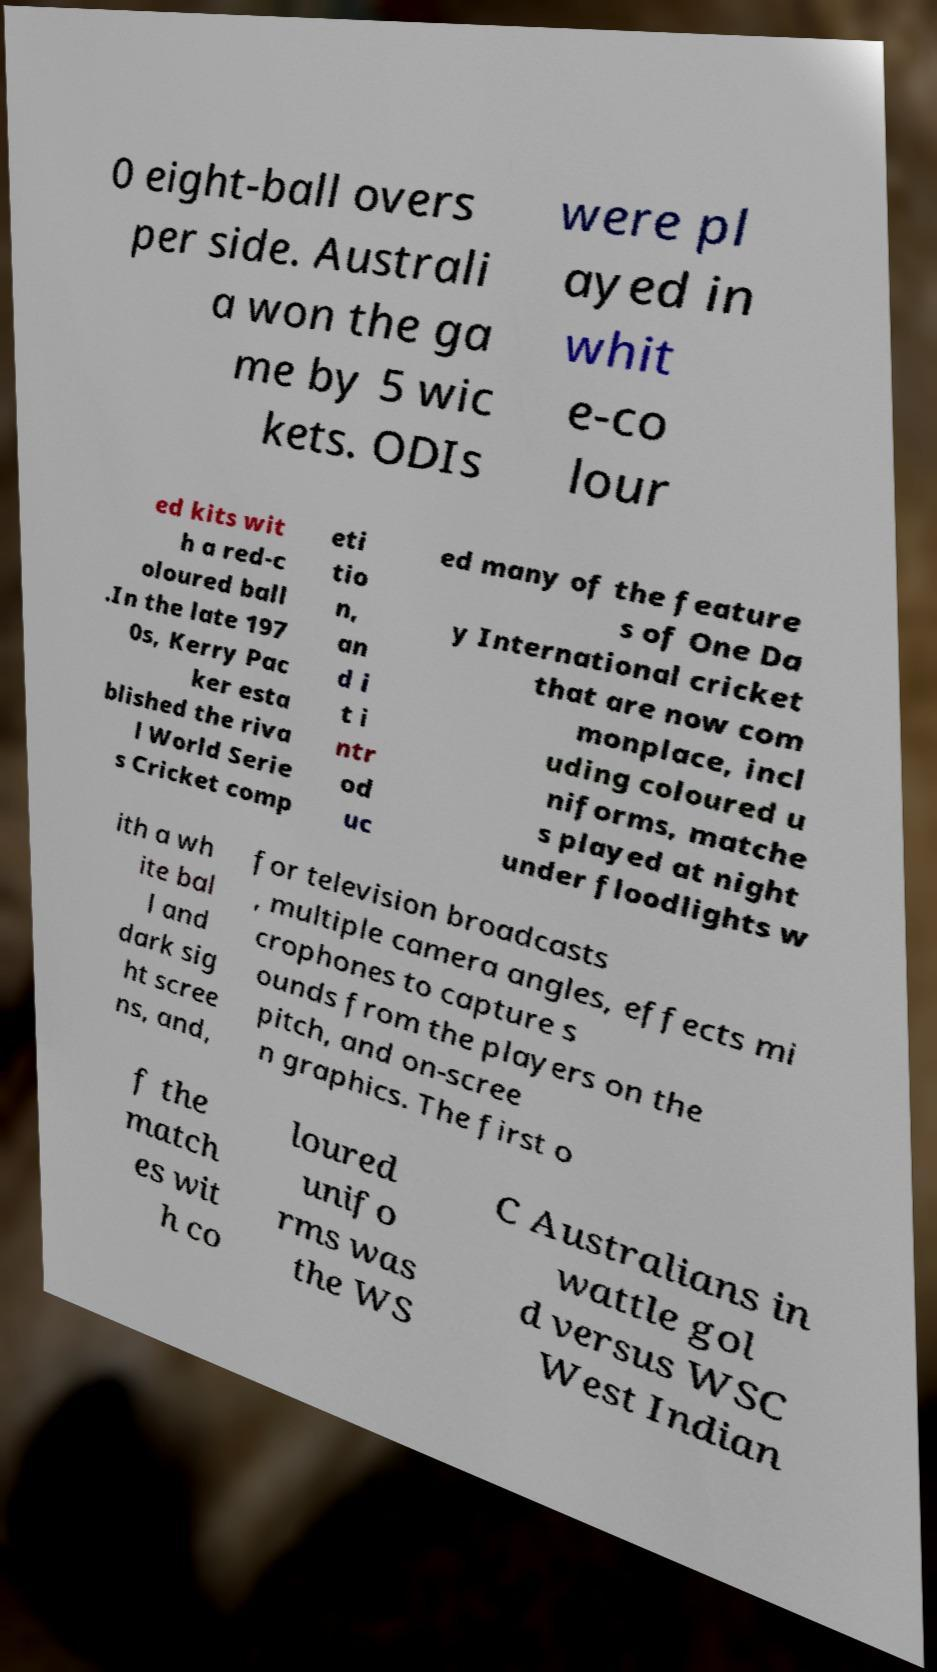I need the written content from this picture converted into text. Can you do that? 0 eight-ball overs per side. Australi a won the ga me by 5 wic kets. ODIs were pl ayed in whit e-co lour ed kits wit h a red-c oloured ball .In the late 197 0s, Kerry Pac ker esta blished the riva l World Serie s Cricket comp eti tio n, an d i t i ntr od uc ed many of the feature s of One Da y International cricket that are now com monplace, incl uding coloured u niforms, matche s played at night under floodlights w ith a wh ite bal l and dark sig ht scree ns, and, for television broadcasts , multiple camera angles, effects mi crophones to capture s ounds from the players on the pitch, and on-scree n graphics. The first o f the match es wit h co loured unifo rms was the WS C Australians in wattle gol d versus WSC West Indian 